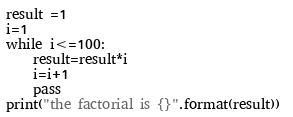Convert code to text. <code><loc_0><loc_0><loc_500><loc_500><_Python_>result =1
i=1
while i<=100:
	result=result*i
	i=i+1
	pass
print("the factorial is {}".format(result)) </code> 